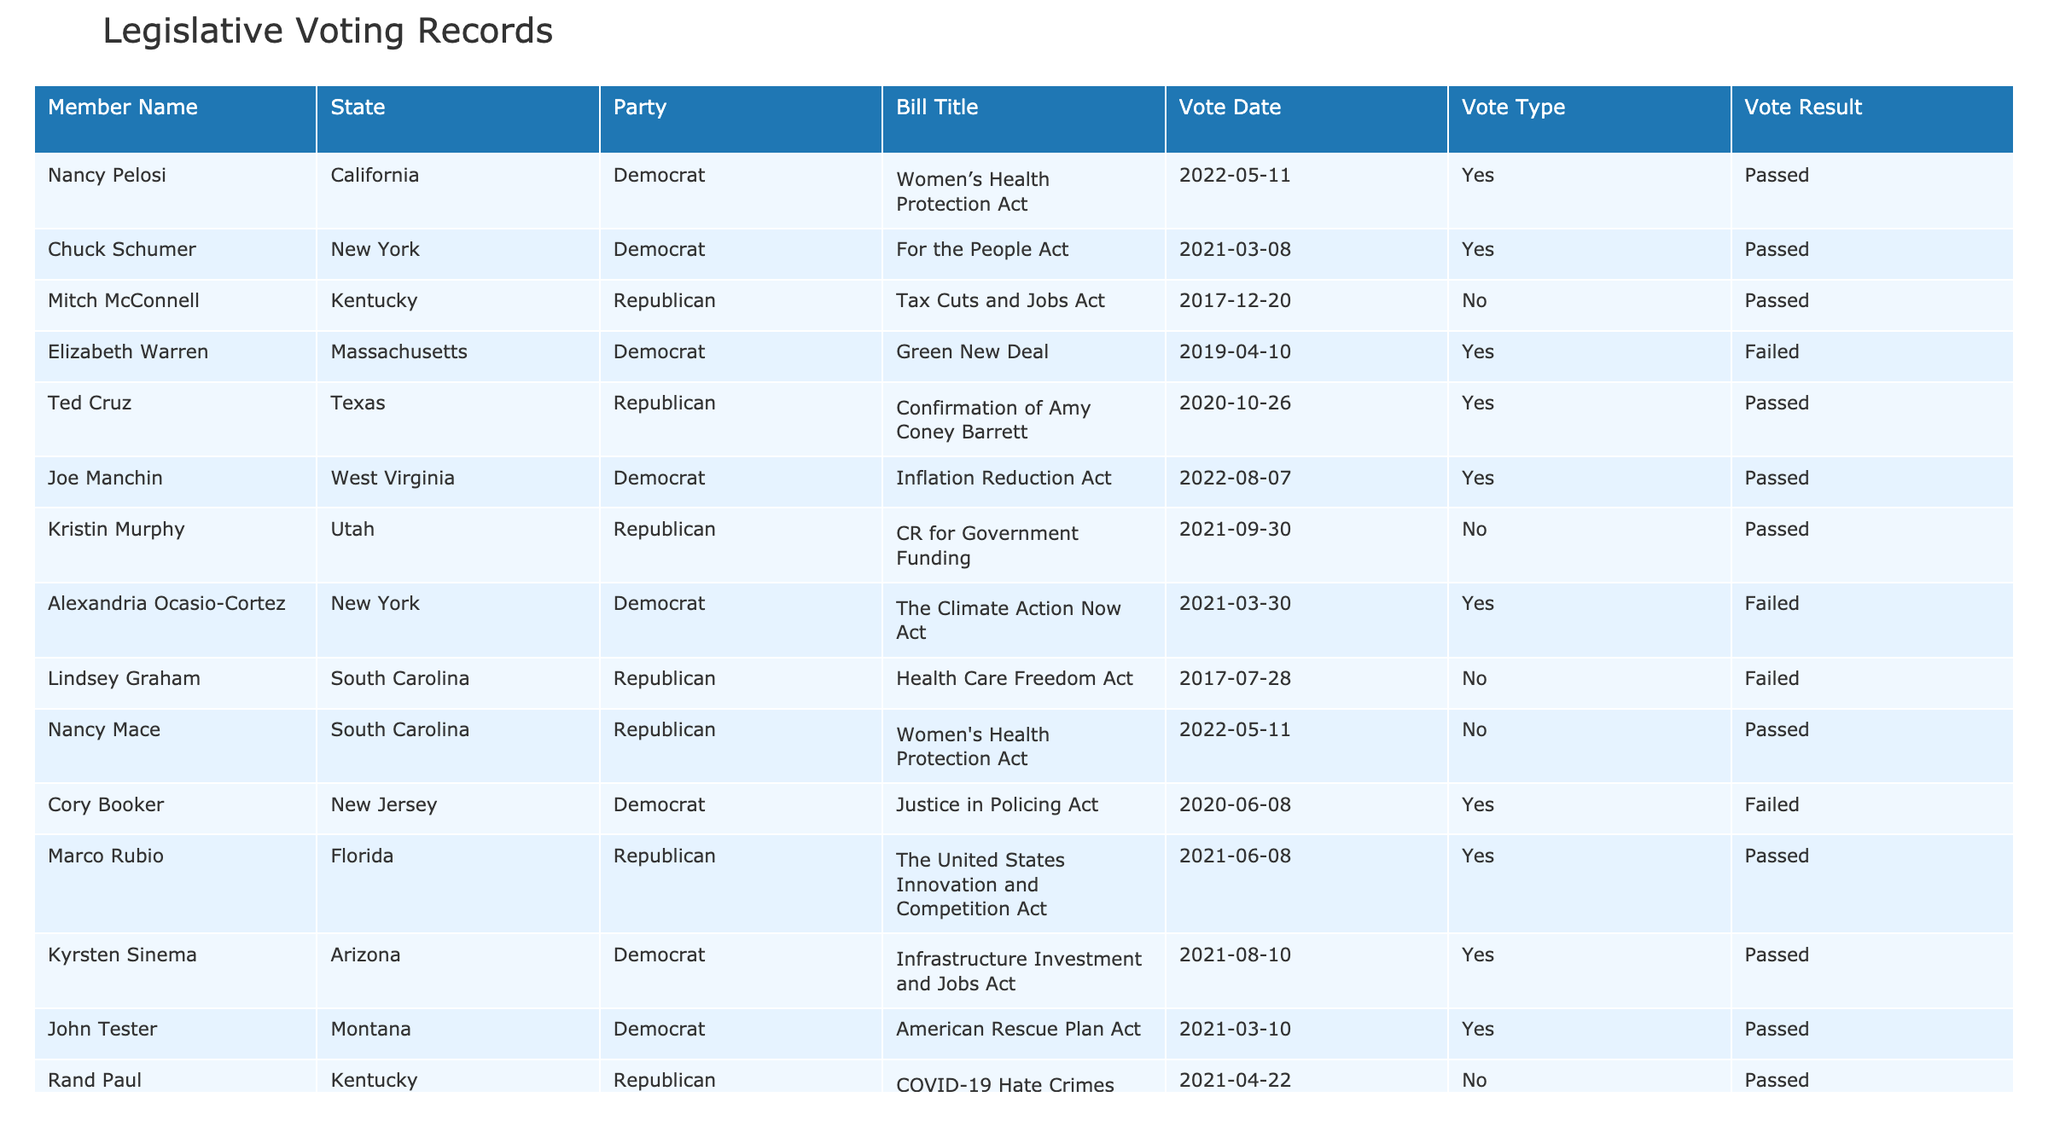What is the title of the bill that Nancy Pelosi voted 'Yes' on? In the table, we find that Nancy Pelosi, a member from California, voted 'Yes' on the 'Women’s Health Protection Act' on the date '2022-05-11'.
Answer: Women’s Health Protection Act How many bills did Mitch McConnell vote on? Looking at Mitch McConnell’s row in the table, we see that he voted on one bill titled 'Tax Cuts and Jobs Act'. Thus, he voted on 1 bill in total.
Answer: 1 Did any Democrat vote against the 'Women's Health Protection Act'? In the table, we can observe that Nancy Mace, a Republican, voted 'No' on the 'Women's Health Protection Act', but there is no Democrat listed as voting 'No' on this bill. Therefore, the answer is no.
Answer: No How many bills passed with a 'Yes' vote from Democrats? Analyzing the table, we count how many 'Yes' votes from Democrats resulted in 'Passed': Nancy Pelosi, Chuck Schumer, Joe Manchin, Kyrsten Sinema, John Tester voted 'Yes' on bills that passed, totaling 5.
Answer: 5 What was the result of the 'Green New Deal' bill? The table indicates that the 'Green New Deal' bill saw a 'Yes' vote from Elizabeth Warren but ultimately 'Failed'.
Answer: Failed Which state had the most members voting on controversial bills? By inspecting the table, we see that New York has two members (Chuck Schumer and Alexandria Ocasio-Cortez) voting on bills. Other states have fewer members. Thus, New York had the most members voting.
Answer: New York What percentage of bills passed based on the votes listed? We have a total of 12 bills listed. Out of these, 7 are marked as 'Passed'. To find the percentage, we calculate (7/12)*100 = 58.33%. Therefore, approximately 58.33% of the bills passed.
Answer: 58.33% Who is the only Republican to vote 'Yes' on the 'Confirmation of Amy Coney Barrett'? By looking at the table, we see that Ted Cruz, from Texas, is the only Republican listed who voted 'Yes' on the 'Confirmation of Amy Coney Barrett'.
Answer: Ted Cruz Was there a bill that passed with only Republican votes? The table shows the 'Tax Cuts and Jobs Act' is one bill that passed where Mitch McConnell, a Republican, voted 'No' but it still passed, suggesting other Republicans voted 'Yes'. Therefore, yes, there was.
Answer: Yes How many bills failed according to the table? Evaluating the table, the following bills are indicated to have 'Failed': 'Green New Deal', 'Justice in Policing Act', and 'Women’s Health Protection Act', which totals 3 failed bills.
Answer: 3 Did any Democrat vote 'No' on the 'CR for Government Funding'? The table lists Kristin Murphy as a Republican voting 'No' on the CR for Government Funding, with no Democrats listed as voting 'No'. Therefore, the answer is no.
Answer: No 